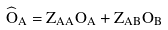<formula> <loc_0><loc_0><loc_500><loc_500>\widehat { O } _ { A } = Z _ { A A } O _ { A } + Z _ { A B } O _ { B }</formula> 